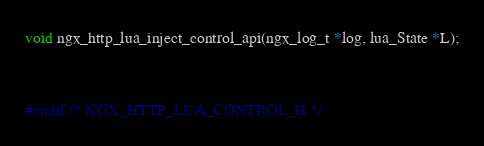Convert code to text. <code><loc_0><loc_0><loc_500><loc_500><_C_>void ngx_http_lua_inject_control_api(ngx_log_t *log, lua_State *L);


#endif /* NGX_HTTP_LUA_CONTROL_H */

</code> 